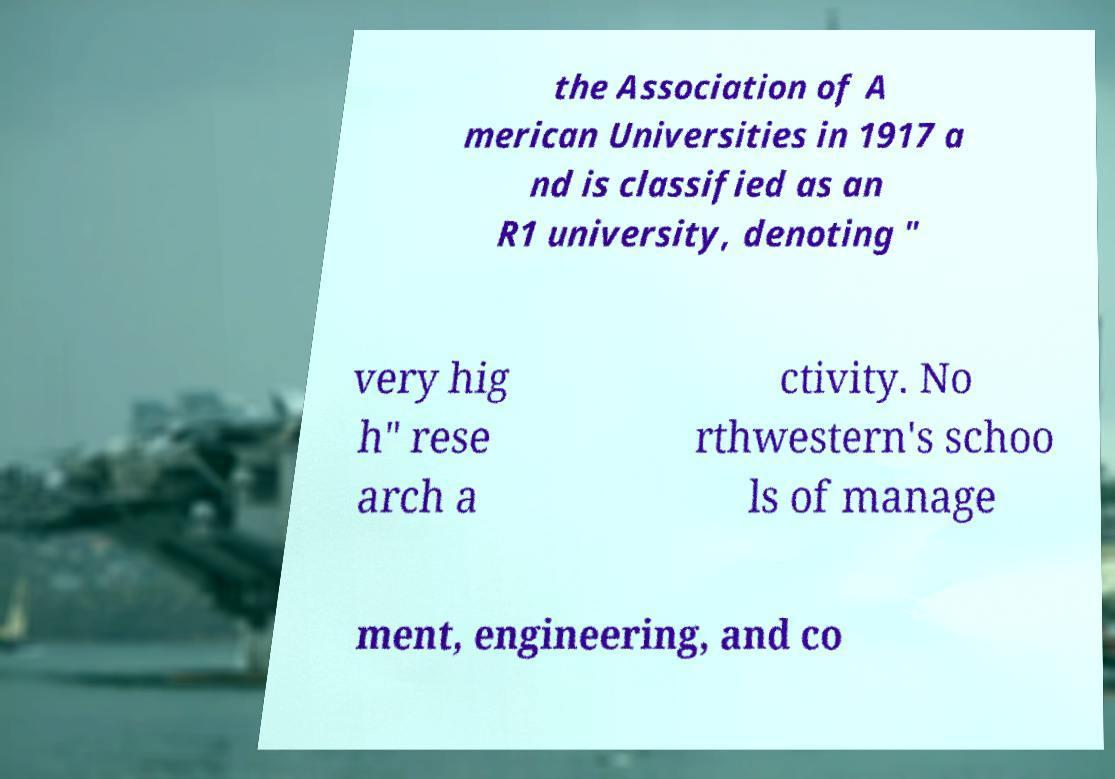Can you accurately transcribe the text from the provided image for me? the Association of A merican Universities in 1917 a nd is classified as an R1 university, denoting " very hig h" rese arch a ctivity. No rthwestern's schoo ls of manage ment, engineering, and co 